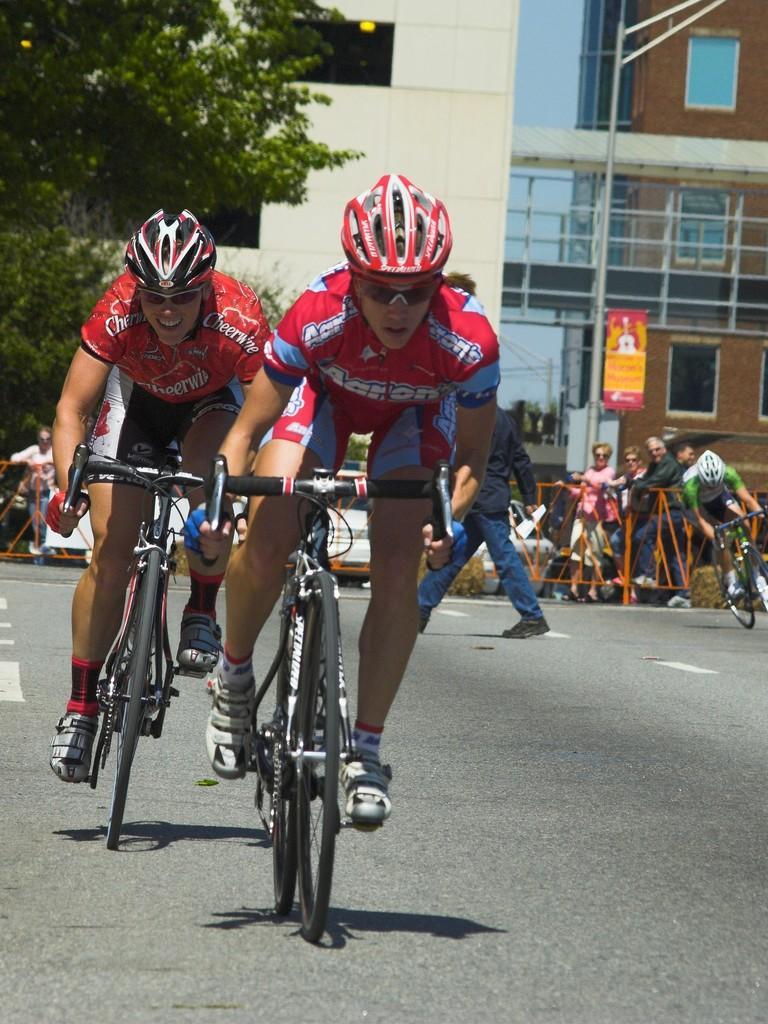Can you describe this image briefly? There are three people riding bicycles on the road and wore helmets, few people standing and this person walking. We can see boards on pole and vehicles. In the background we can see building and trees. 